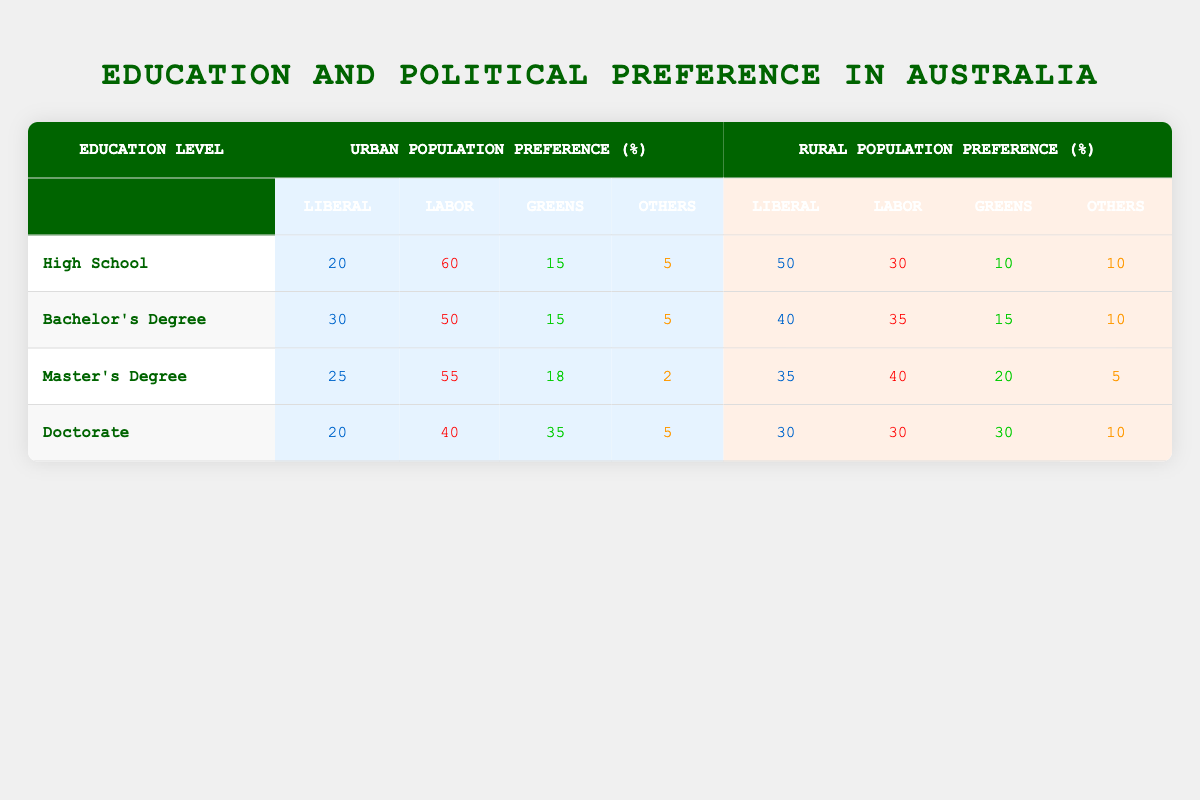What is the urban population preference for the Labor party among those with a Doctorate? In the table, under the "Urban Population Preference (%)" column for the "Doctorate" row, the percentage for the Labor party is listed as 40.
Answer: 40 What is the total percentage of the Liberal party preference for High School educated individuals in rural areas? The total percentage for the rural population preference for the Liberal party in the "High School" row is 50.
Answer: 50 Is it true that the Greens have a higher percentage preference in urban areas compared to rural areas for individuals with a Bachelor's Degree? For the "Bachelor's Degree" row, the urban population preference for the Greens is 15, while the rural population preference is also 15. Therefore, the statement is false as they are equal, not higher.
Answer: No What is the difference in percentage preference for the Labor party between urban and rural populations among those with a Master’s Degree? The preference for the Labor party among the urban population in the "Master's Degree" row is 55, and for the rural population, it is 40. The difference is calculated as 55 - 40 = 15.
Answer: 15 What is the average percentage preference for the Liberal party across all education levels in urban populations? The Liberal party percentages for urban populations across all education levels are 20 (High School), 30 (Bachelor's Degree), 25 (Master's Degree), and 20 (Doctorate). Adding these gives 20 + 30 + 25 + 20 = 95. Dividing by 4 (the number of education levels) gives an average of 95 / 4 = 23.75.
Answer: 23.75 How does the preference for the Others category in rural areas compare to that in urban areas for individuals with a Master’s Degree? For individuals with a Master’s Degree, the rural percentage for "Others" is 5, while the urban percentage is 2. Comparing the two, the rural preference is higher.
Answer: Rural preference is higher What is the highest percentage preference for the Greens in urban areas and which education level does it correspond to? The highest urban population preference for the Greens is found in the "Doctorate" row with a percentage of 35.
Answer: 35 Are more individuals with a Bachelor's Degree in urban areas likely to prefer Labor or Liberal? In the "Bachelor's Degree" row for urban populations, the preference for Labor is 50 and for Liberal is 30. Since 50 is greater than 30, more prefer Labor.
Answer: Labor 